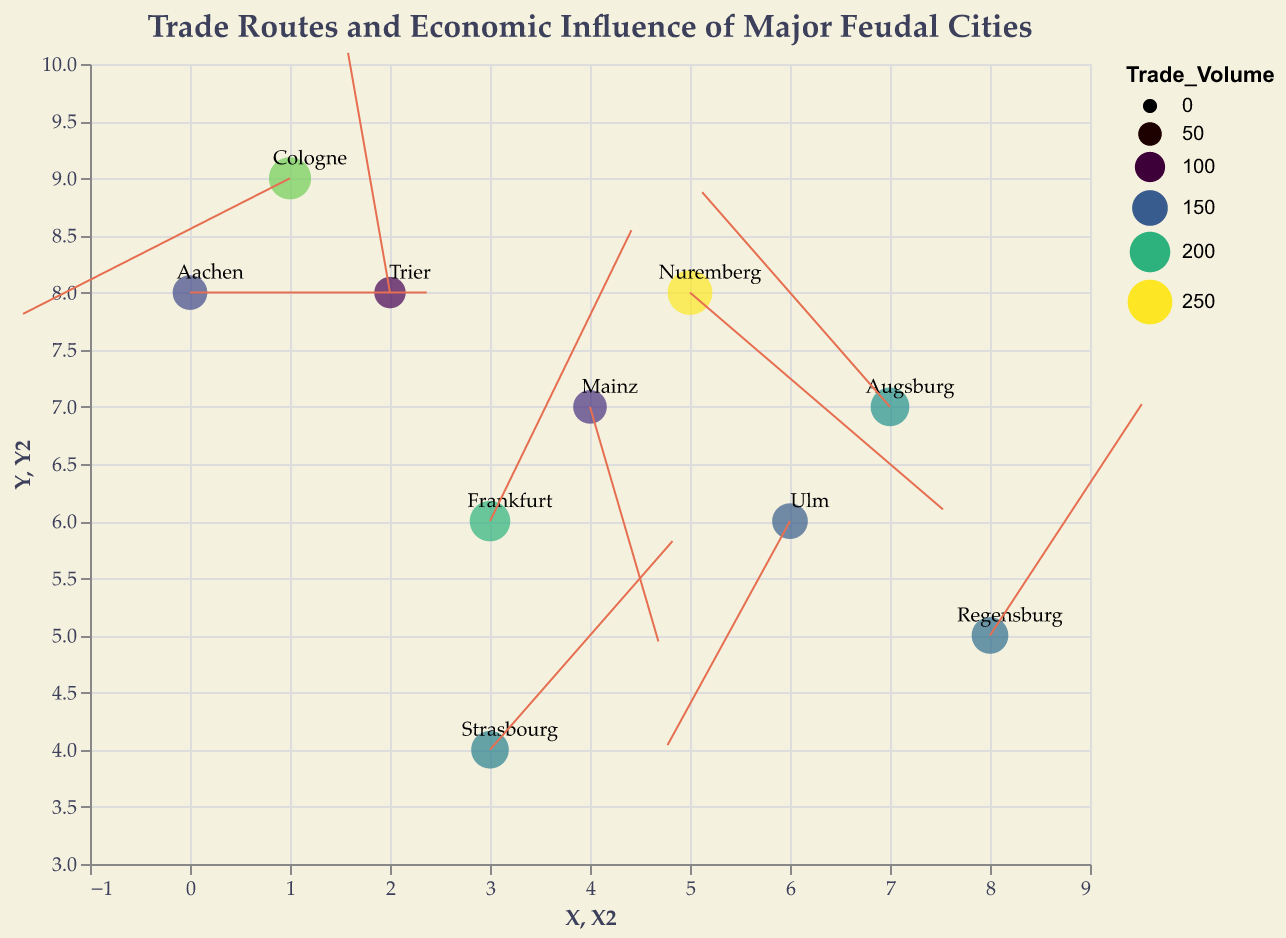How many cities are displayed in the figure? To determine the number of cities displayed in the plot, count the distinct points/elements marked on the graph, each representing a city. The graph has 10 points, indicating 10 cities.
Answer: 10 Which city has the highest trade volume? To find the city with the highest trade volume, look for the point with the largest size. The tooltip or label can be used to identify the city. Nuremberg, with a trade volume of 250, has the largest size.
Answer: Nuremberg Which city has trade routes pointing mostly northward? To determine this, look at the direction of the arrows in the quiver plot. A city whose arrow direction has a positive Y component indicates a northward direction. Frankfurt has a direction vector (0.5, 0.9), which points mostly northward.
Answer: Frankfurt Which city has the smallest trade volume, and what is its direction vector? Examine the sizes of the points on the plot. The smallest point reflects the city with the lowest trade volume. Trier has the smallest trade volume (110) and its direction vector is (-0.2, 1).
Answer: Trier, (-0.2, 1) How many cities have a trade volume greater than 200? Count the points on the plot with sizes that correspond to a trade volume greater than 200. From the data, Nuremberg (250) and Cologne (220) meet this criterion.
Answer: 2 Which city has a trade route direction vector pointing southwest? A southwest direction has a negative X component and a negative Y component. By checking the direction vectors, Cologne fits this with (-0.9, -0.4).
Answer: Cologne Compare the trade volume between Mainz and Ulm. Which city has a larger trade volume? Compare the points that represent Mainz and Ulm by examining their sizes and using the tooltip for precise values. Mainz has a trade volume of 130, while Ulm has 150. Therefore, Ulm has a larger trade volume.
Answer: Ulm Identify the city whose trade route points directly to the east. A direction vector pointing directly east would have (1, 0). Checking direction vectors, Aachen fits this with (1, 0).
Answer: Aachen Which city is furthest west on the plot, and what is its trade volume? To find the city furthest west, identify the point with the smallest X coordinate. Aachen, with an X coordinate of 0, is the furthest west, and its trade volume is 140.
Answer: Aachen, 140 